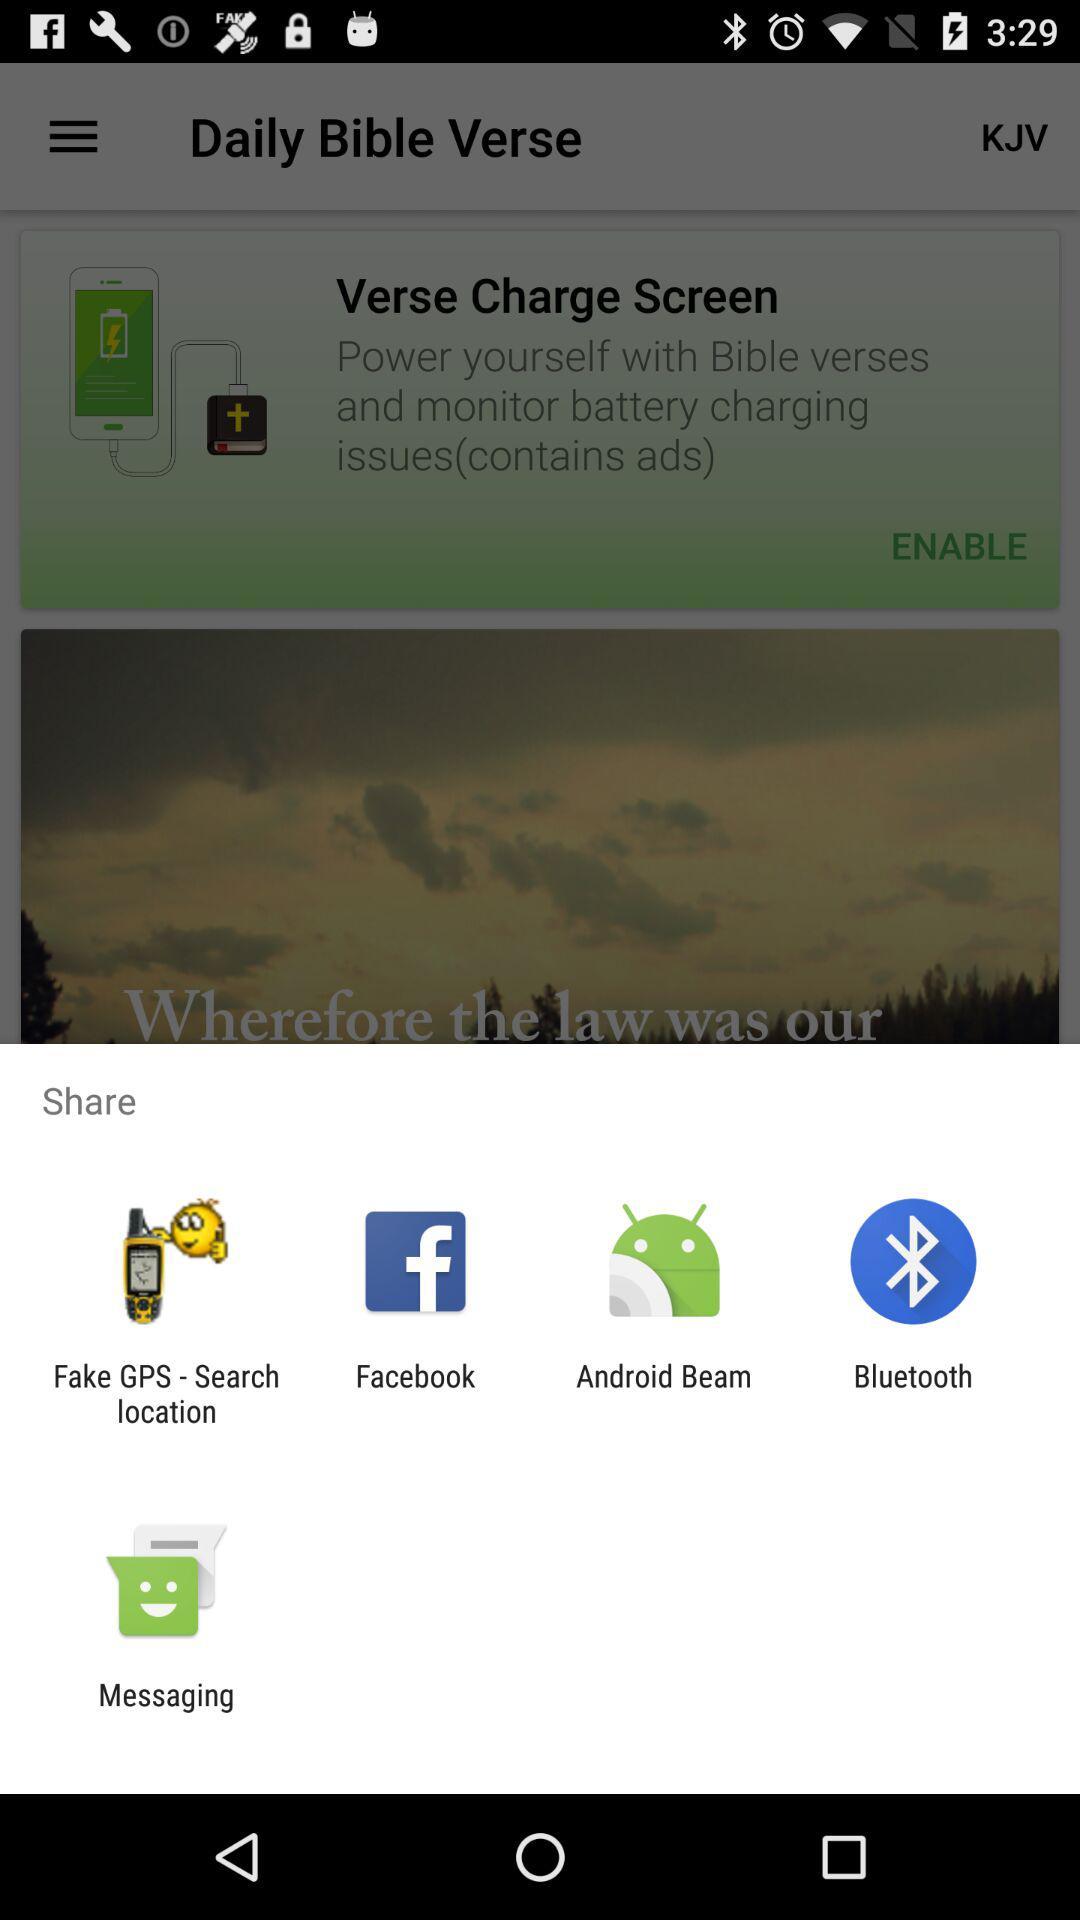Through which application can we share? You can share through "Fake GPS - Search location", "Facebook", "Android Beam", "Bluetooth" and "Messaging". 